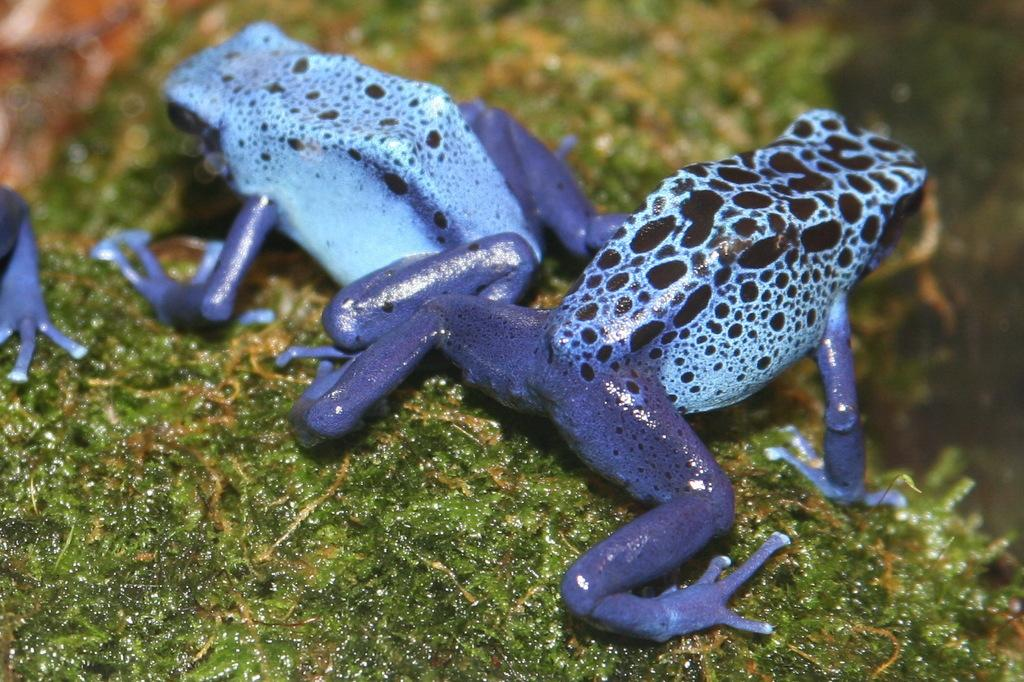What type of animals are present in the image? There are frogs in the image. What is the color of the surface on which the frogs are located? The frogs are on a green surface. What is the name of the frog that is swimming in the image? There is no frog swimming in the image, and therefore no name can be provided. 